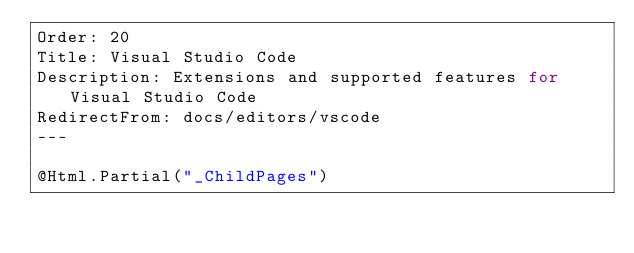<code> <loc_0><loc_0><loc_500><loc_500><_C#_>Order: 20
Title: Visual Studio Code
Description: Extensions and supported features for Visual Studio Code
RedirectFrom: docs/editors/vscode
---

@Html.Partial("_ChildPages")</code> 